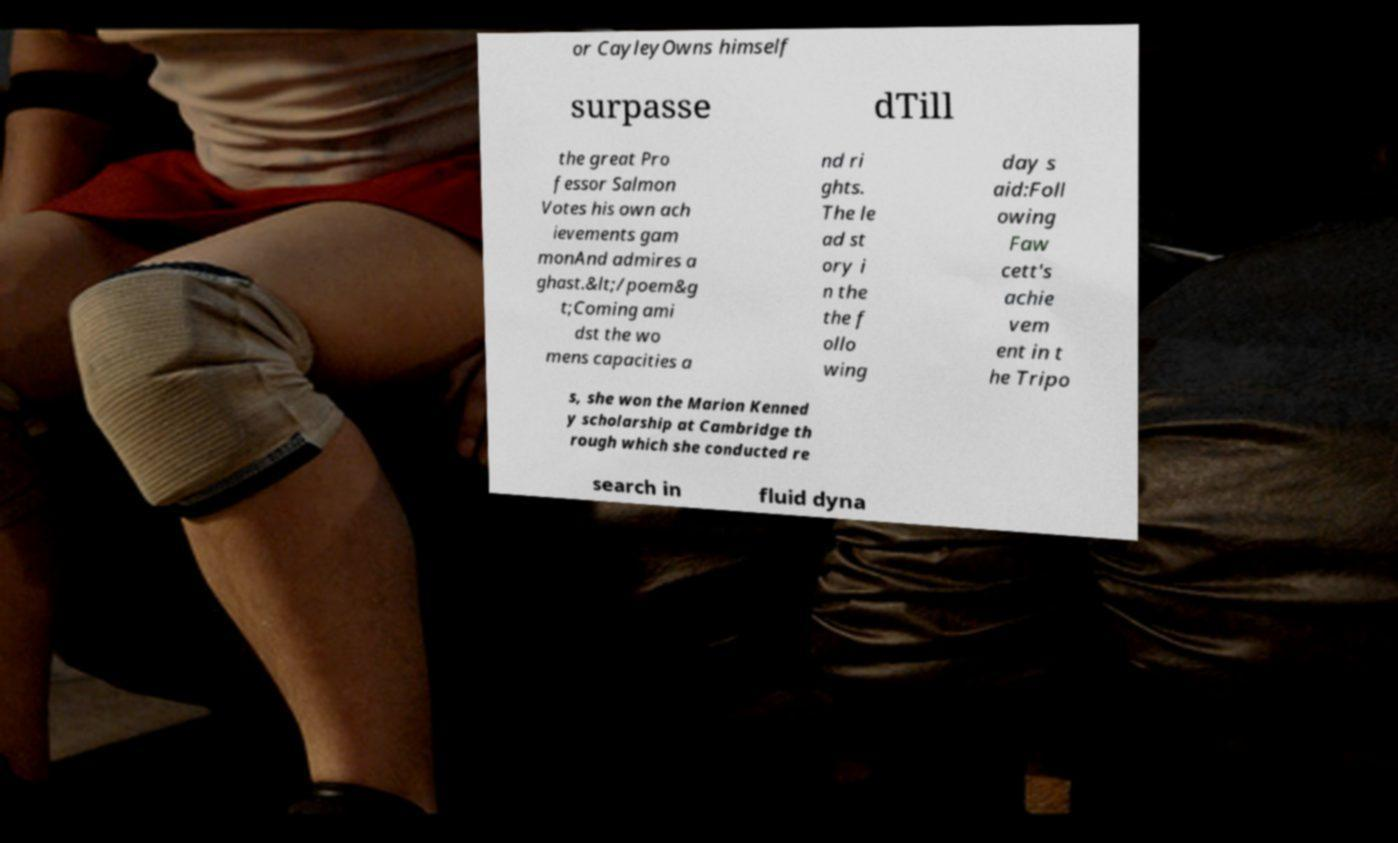What messages or text are displayed in this image? I need them in a readable, typed format. or CayleyOwns himself surpasse dTill the great Pro fessor Salmon Votes his own ach ievements gam monAnd admires a ghast.&lt;/poem&g t;Coming ami dst the wo mens capacities a nd ri ghts. The le ad st ory i n the the f ollo wing day s aid:Foll owing Faw cett's achie vem ent in t he Tripo s, she won the Marion Kenned y scholarship at Cambridge th rough which she conducted re search in fluid dyna 